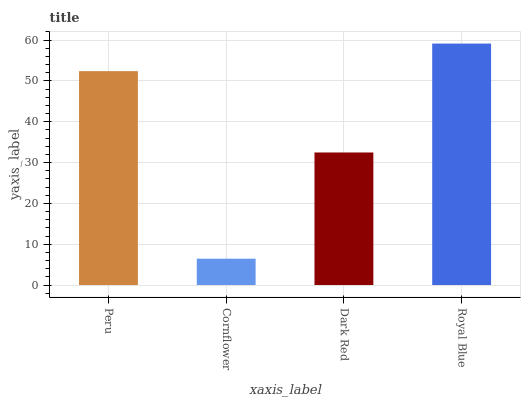Is Cornflower the minimum?
Answer yes or no. Yes. Is Royal Blue the maximum?
Answer yes or no. Yes. Is Dark Red the minimum?
Answer yes or no. No. Is Dark Red the maximum?
Answer yes or no. No. Is Dark Red greater than Cornflower?
Answer yes or no. Yes. Is Cornflower less than Dark Red?
Answer yes or no. Yes. Is Cornflower greater than Dark Red?
Answer yes or no. No. Is Dark Red less than Cornflower?
Answer yes or no. No. Is Peru the high median?
Answer yes or no. Yes. Is Dark Red the low median?
Answer yes or no. Yes. Is Royal Blue the high median?
Answer yes or no. No. Is Royal Blue the low median?
Answer yes or no. No. 